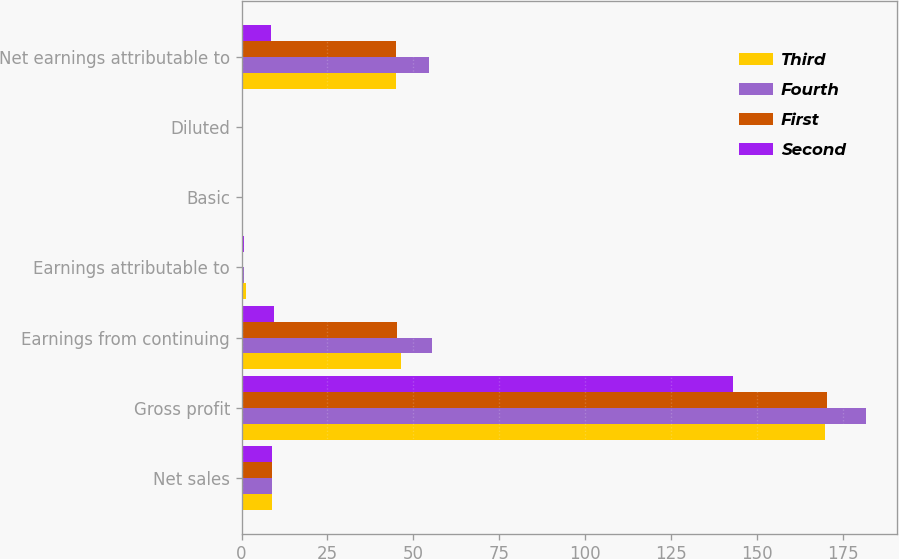<chart> <loc_0><loc_0><loc_500><loc_500><stacked_bar_chart><ecel><fcel>Net sales<fcel>Gross profit<fcel>Earnings from continuing<fcel>Earnings attributable to<fcel>Basic<fcel>Diluted<fcel>Net earnings attributable to<nl><fcel>Third<fcel>9<fcel>170<fcel>46.3<fcel>1.3<fcel>0.3<fcel>0.3<fcel>45<nl><fcel>Fourth<fcel>9<fcel>181.9<fcel>55.5<fcel>0.8<fcel>0.38<fcel>0.37<fcel>54.7<nl><fcel>First<fcel>9<fcel>170.4<fcel>45.3<fcel>0.4<fcel>0.31<fcel>0.31<fcel>44.9<nl><fcel>Second<fcel>9<fcel>143<fcel>9.3<fcel>0.6<fcel>0.06<fcel>0.06<fcel>8.7<nl></chart> 